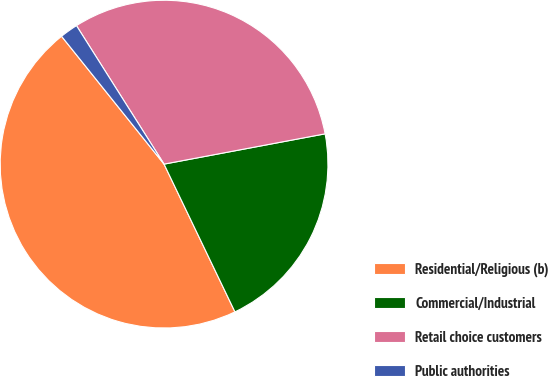Convert chart to OTSL. <chart><loc_0><loc_0><loc_500><loc_500><pie_chart><fcel>Residential/Religious (b)<fcel>Commercial/Industrial<fcel>Retail choice customers<fcel>Public authorities<nl><fcel>46.37%<fcel>20.84%<fcel>31.02%<fcel>1.78%<nl></chart> 